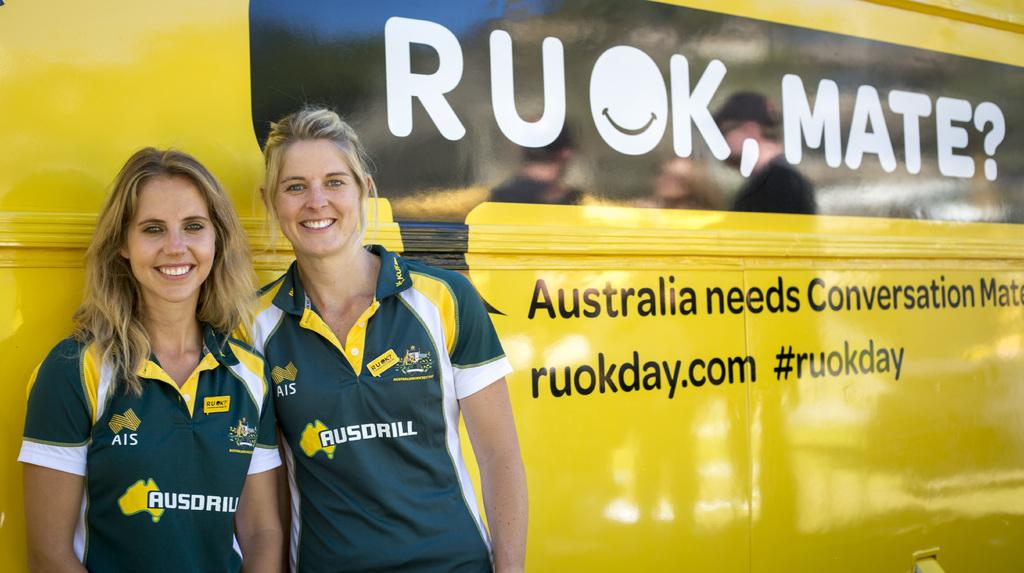How many people are in the image? There are two ladies in the image. What are the ladies doing in the image? The ladies are standing in front of a bus. What type of sheet is being used to create a zephyr in the image? There is no sheet or zephyr present in the image; it features two ladies standing in front of a bus. 